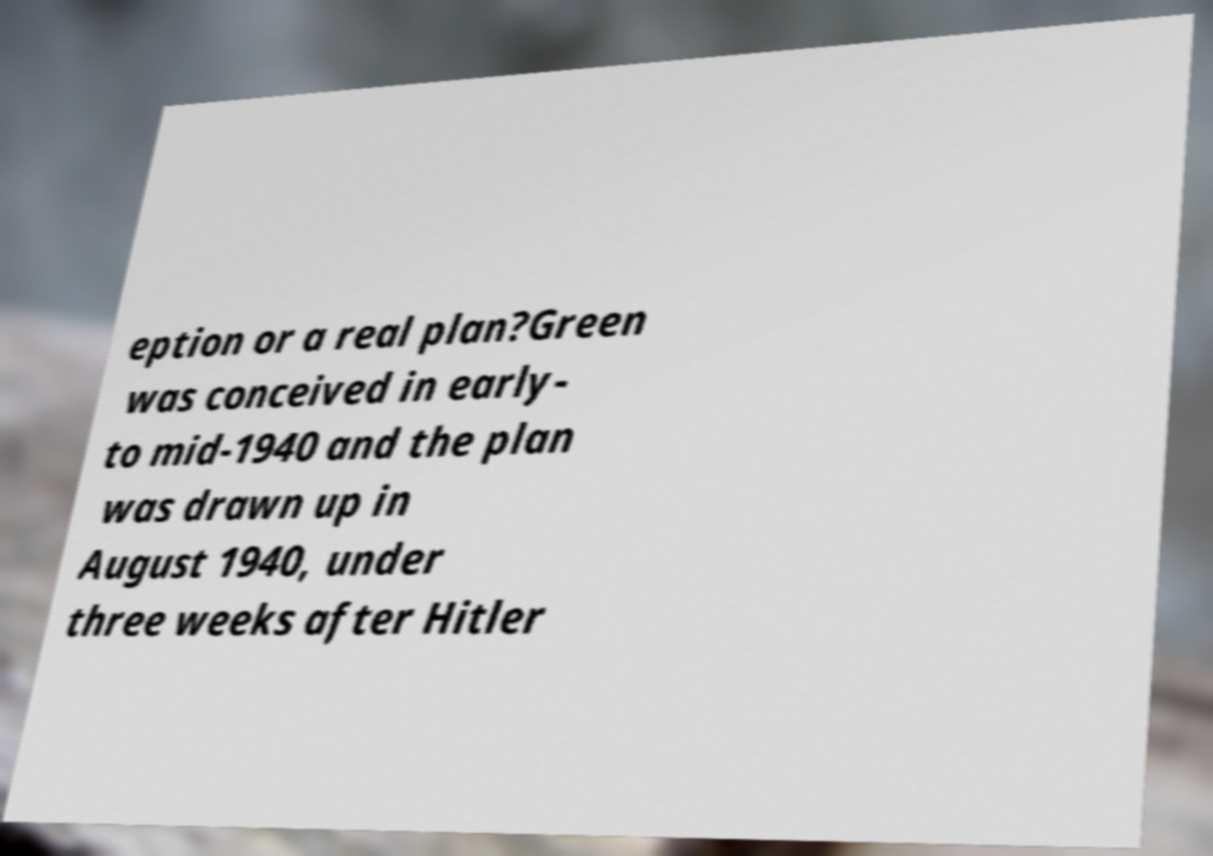There's text embedded in this image that I need extracted. Can you transcribe it verbatim? eption or a real plan?Green was conceived in early- to mid-1940 and the plan was drawn up in August 1940, under three weeks after Hitler 